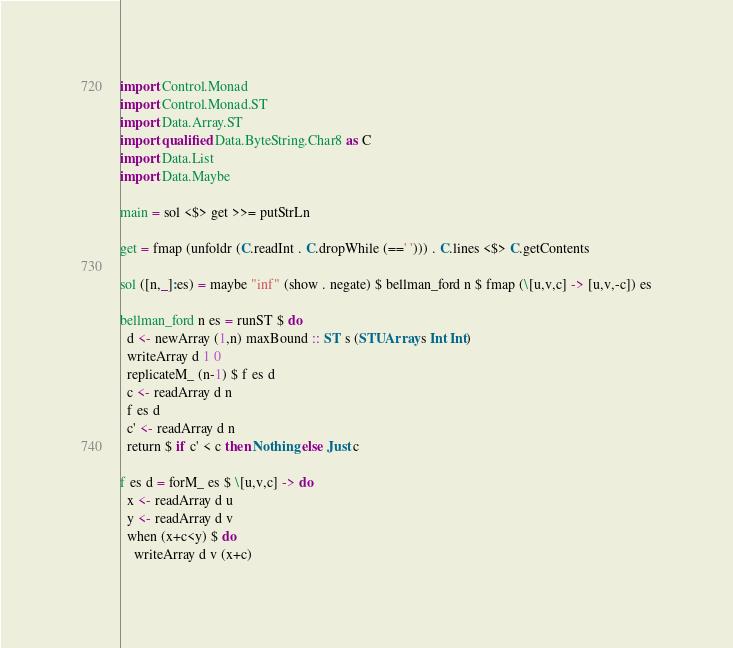<code> <loc_0><loc_0><loc_500><loc_500><_Haskell_>import Control.Monad
import Control.Monad.ST
import Data.Array.ST
import qualified Data.ByteString.Char8 as C
import Data.List
import Data.Maybe

main = sol <$> get >>= putStrLn

get = fmap (unfoldr (C.readInt . C.dropWhile (==' '))) . C.lines <$> C.getContents  

sol ([n,_]:es) = maybe "inf" (show . negate) $ bellman_ford n $ fmap (\[u,v,c] -> [u,v,-c]) es

bellman_ford n es = runST $ do
  d <- newArray (1,n) maxBound :: ST s (STUArray s Int Int)
  writeArray d 1 0
  replicateM_ (n-1) $ f es d
  c <- readArray d n
  f es d
  c' <- readArray d n
  return $ if c' < c then Nothing else Just c

f es d = forM_ es $ \[u,v,c] -> do
  x <- readArray d u
  y <- readArray d v
  when (x+c<y) $ do
    writeArray d v (x+c)</code> 